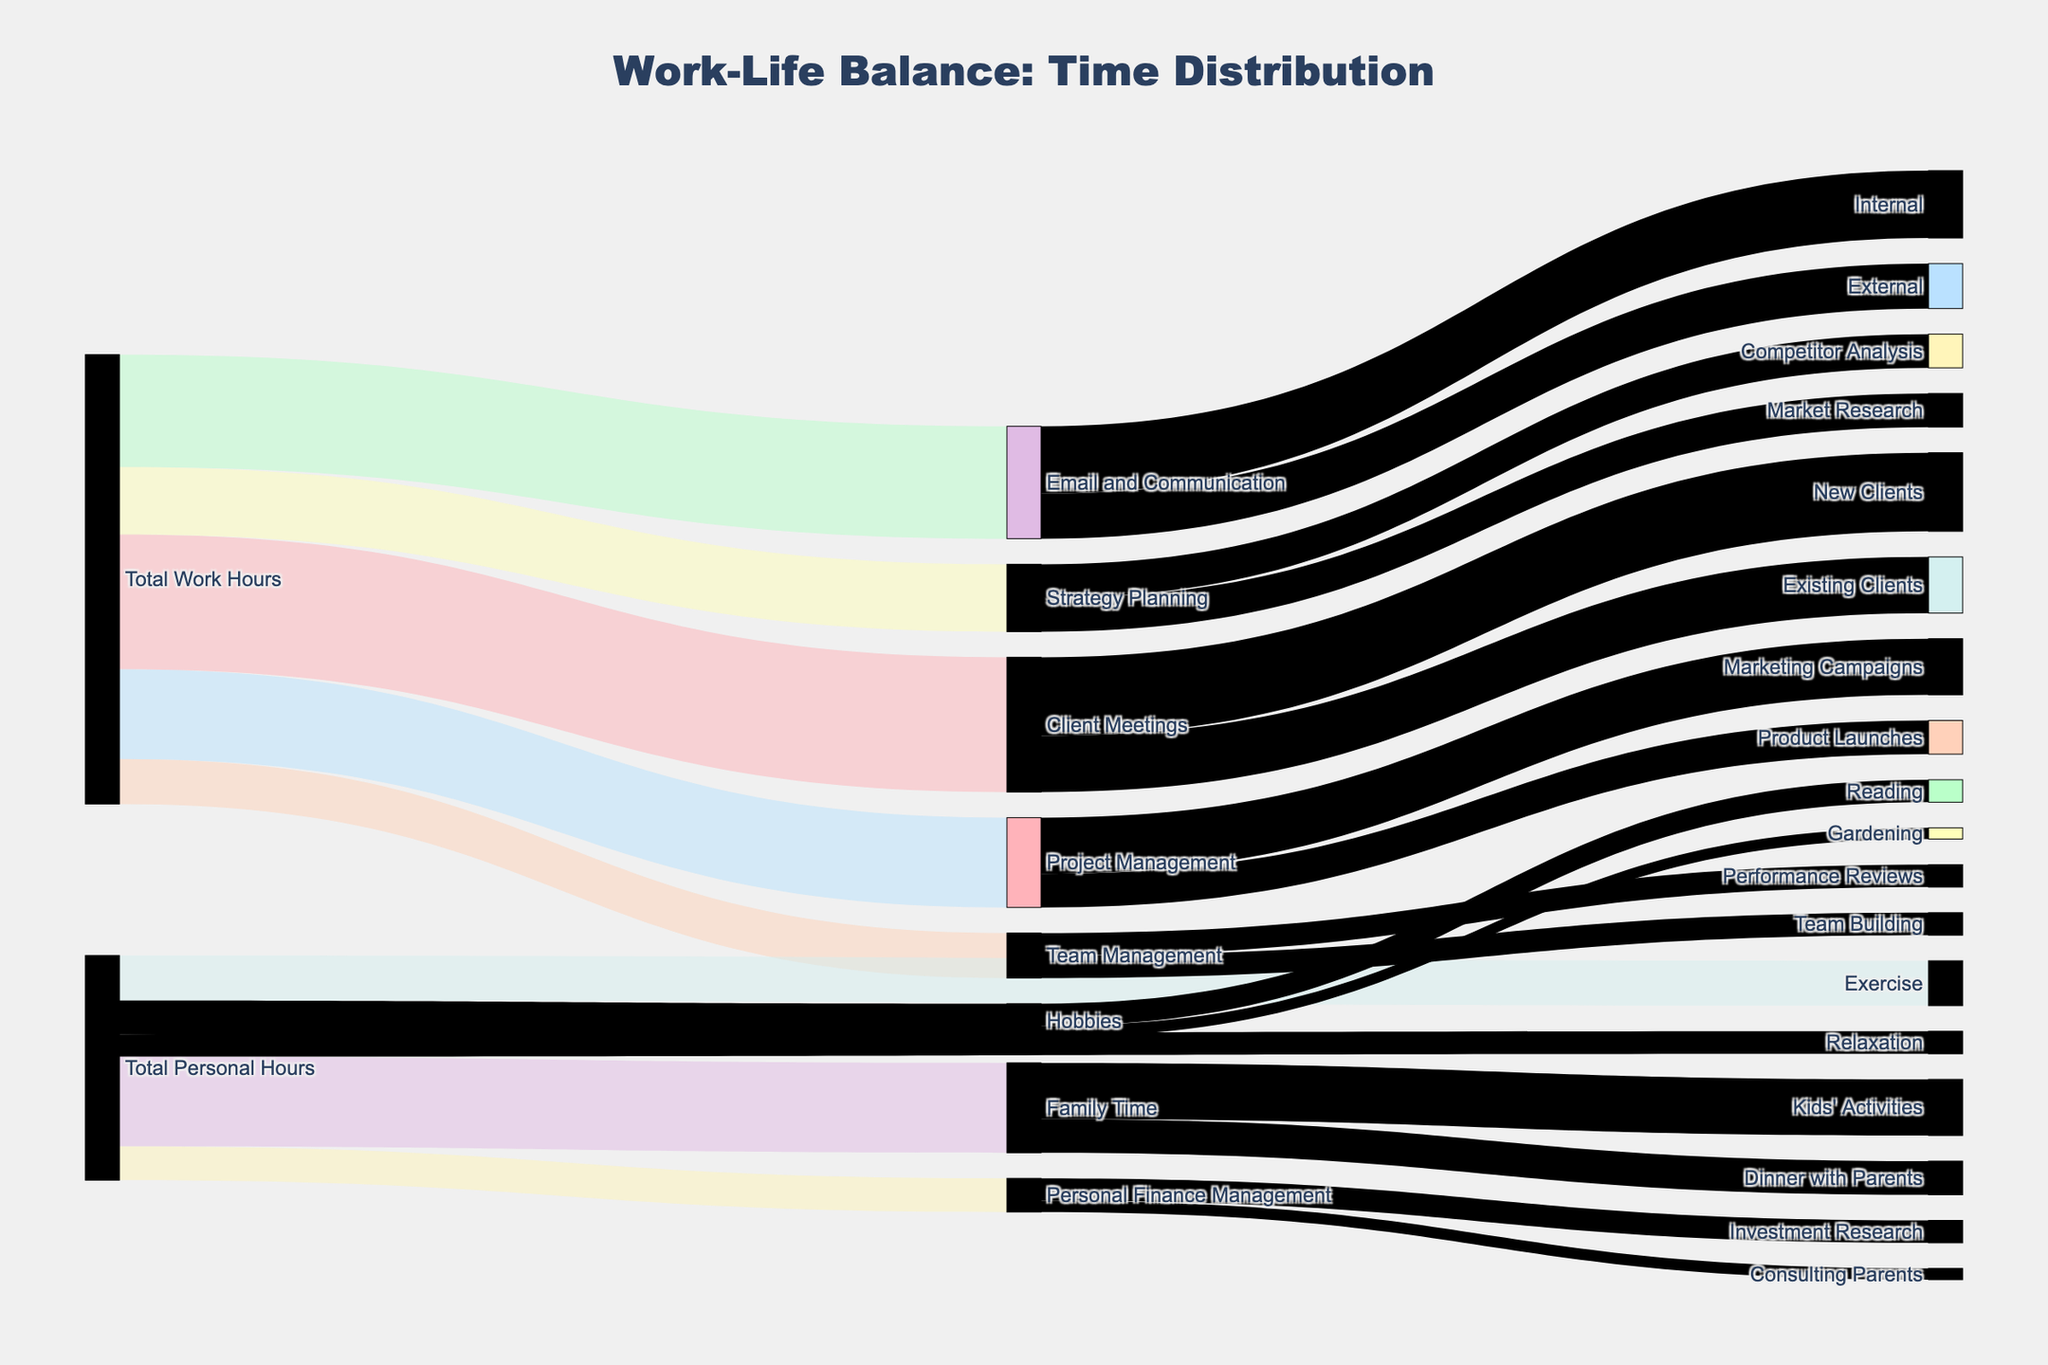What is the title of the Sankey Diagram? The title of the Sankey Diagram is mentioned at the top of the figure.
Answer: Work-Life Balance: Time Distribution What is the total time allocated to Email and Communication? The figure has a link from "Total Work Hours" to "Email and Communication" with the value indicating the time spent.
Answer: 10 hours What is the overall time spent on Client Meetings with New Clients? To find this, look at the link from "Client Meetings" to "New Clients".
Answer: 7 hours How many hours are dedicated to Strategy Planning activities in total? Sum the values of the links from "Total Work Hours" to "Market Research" and "Competitor Analysis".
Answer: 6 hours Which personal activity receives the least amount of time? Identify the smallest value among the targets under "Total Personal Hours".
Answer: Relaxation (2 hours) How many hours are spent on Performance Reviews and Team Building together? Examine the values of links connected to "Performance Reviews" and "Team Building", then sum them up.
Answer: 4 hours What is the combined time spent on Family Time and Hobbies? Sum the values of the links from "Total Personal Hours" to "Family Time" and "Hobbies".
Answer: 11 hours Does more time go to Client Meetings or Project Management? Compare the values of the links from "Total Work Hours" to "Client Meetings" and "Project Management".
Answer: Client Meetings (12 hours vs 8 hours) Which sub-task under Client Meetings consumes more time? Compare the values of the links from "Client Meetings" to "New Clients" and "Existing Clients".
Answer: New Clients (7 hours vs 5 hours) How does the time spent on Consulting Parents compare to Investment Research? Compare the value of the link from "Personal Finance Management" to "Consulting Parents" with the one to "Investment Research".
Answer: Consulting Parents (1 hour vs 2 hours) 